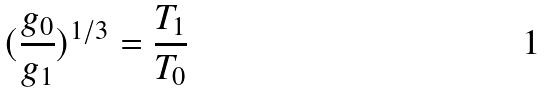Convert formula to latex. <formula><loc_0><loc_0><loc_500><loc_500>( \frac { g _ { 0 } } { g _ { 1 } } ) ^ { 1 / 3 } = \frac { T _ { 1 } } { T _ { 0 } }</formula> 